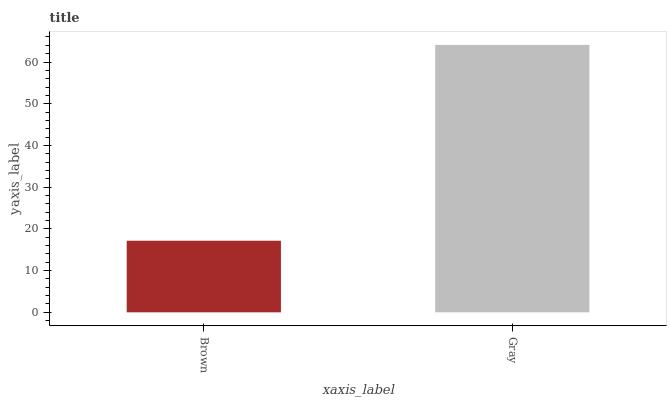Is Brown the minimum?
Answer yes or no. Yes. Is Gray the maximum?
Answer yes or no. Yes. Is Gray the minimum?
Answer yes or no. No. Is Gray greater than Brown?
Answer yes or no. Yes. Is Brown less than Gray?
Answer yes or no. Yes. Is Brown greater than Gray?
Answer yes or no. No. Is Gray less than Brown?
Answer yes or no. No. Is Gray the high median?
Answer yes or no. Yes. Is Brown the low median?
Answer yes or no. Yes. Is Brown the high median?
Answer yes or no. No. Is Gray the low median?
Answer yes or no. No. 